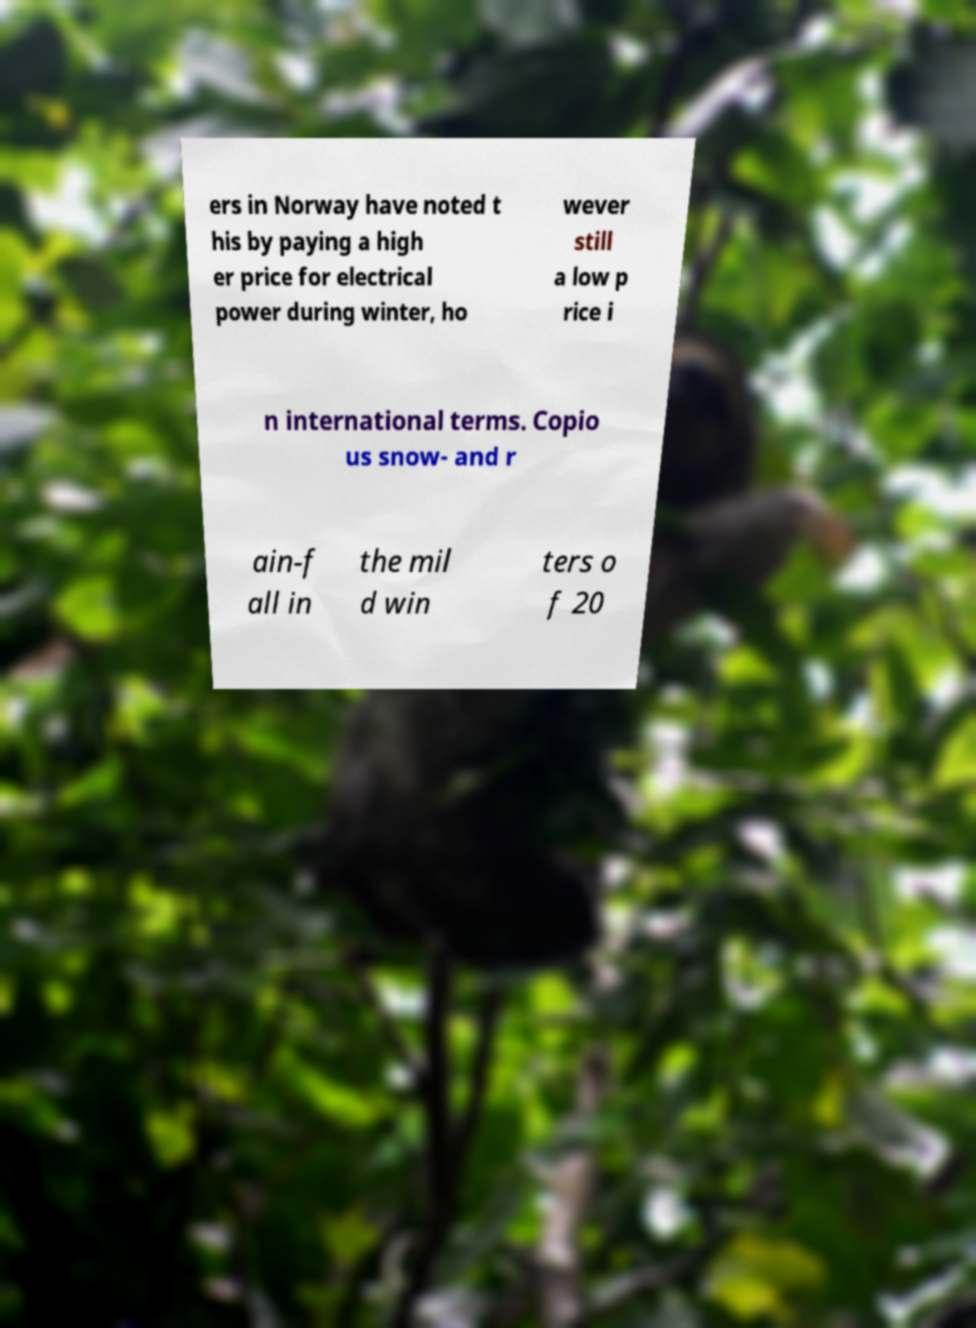Could you assist in decoding the text presented in this image and type it out clearly? ers in Norway have noted t his by paying a high er price for electrical power during winter, ho wever still a low p rice i n international terms. Copio us snow- and r ain-f all in the mil d win ters o f 20 